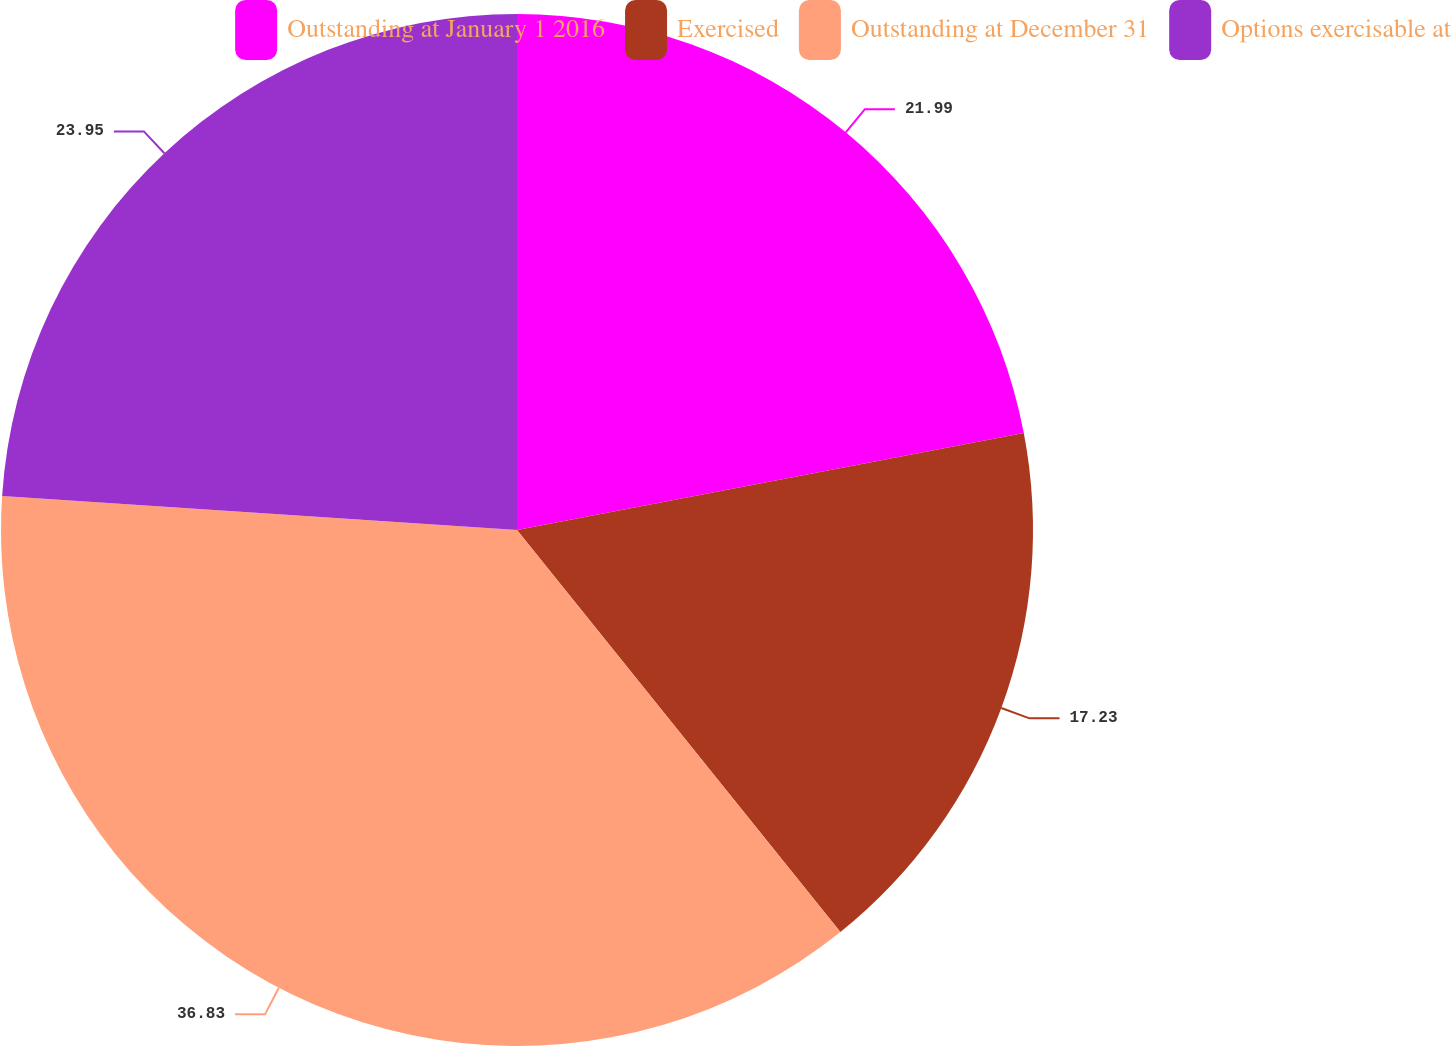<chart> <loc_0><loc_0><loc_500><loc_500><pie_chart><fcel>Outstanding at January 1 2016<fcel>Exercised<fcel>Outstanding at December 31<fcel>Options exercisable at<nl><fcel>21.99%<fcel>17.23%<fcel>36.83%<fcel>23.95%<nl></chart> 